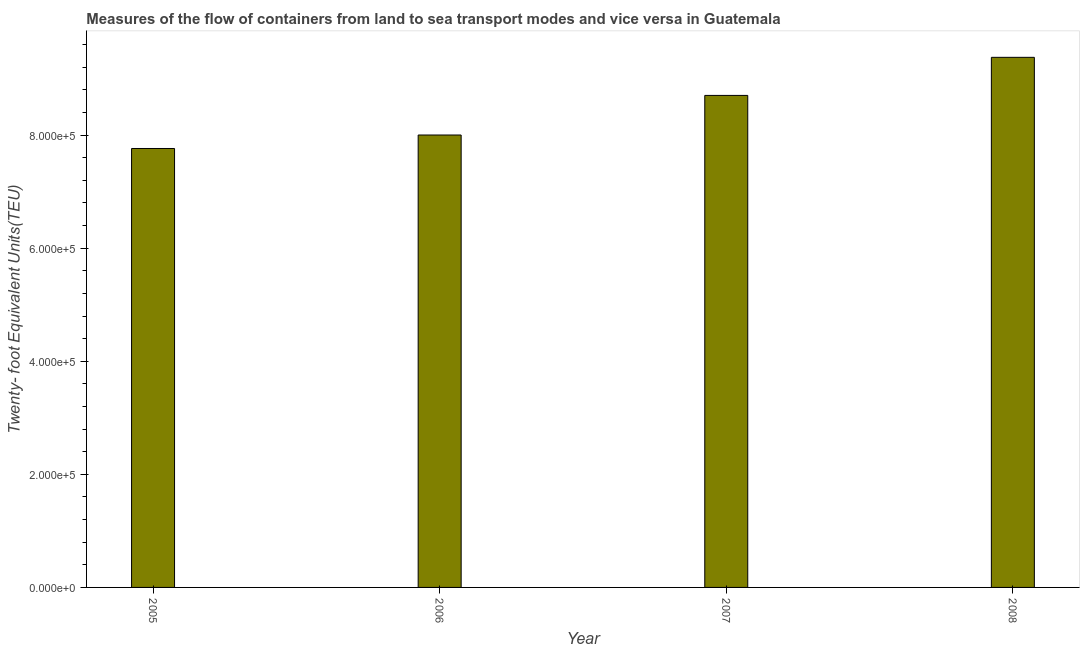Does the graph contain any zero values?
Your answer should be very brief. No. Does the graph contain grids?
Ensure brevity in your answer.  No. What is the title of the graph?
Ensure brevity in your answer.  Measures of the flow of containers from land to sea transport modes and vice versa in Guatemala. What is the label or title of the X-axis?
Provide a succinct answer. Year. What is the label or title of the Y-axis?
Provide a short and direct response. Twenty- foot Equivalent Units(TEU). What is the container port traffic in 2007?
Provide a succinct answer. 8.70e+05. Across all years, what is the maximum container port traffic?
Give a very brief answer. 9.38e+05. Across all years, what is the minimum container port traffic?
Provide a short and direct response. 7.76e+05. In which year was the container port traffic maximum?
Your response must be concise. 2008. What is the sum of the container port traffic?
Your answer should be very brief. 3.38e+06. What is the difference between the container port traffic in 2007 and 2008?
Ensure brevity in your answer.  -6.74e+04. What is the average container port traffic per year?
Your answer should be compact. 8.46e+05. What is the median container port traffic?
Provide a short and direct response. 8.35e+05. What is the ratio of the container port traffic in 2006 to that in 2008?
Offer a very short reply. 0.85. Is the container port traffic in 2006 less than that in 2008?
Your answer should be compact. Yes. What is the difference between the highest and the second highest container port traffic?
Ensure brevity in your answer.  6.74e+04. Is the sum of the container port traffic in 2007 and 2008 greater than the maximum container port traffic across all years?
Provide a short and direct response. Yes. What is the difference between the highest and the lowest container port traffic?
Your answer should be compact. 1.61e+05. In how many years, is the container port traffic greater than the average container port traffic taken over all years?
Provide a short and direct response. 2. Are all the bars in the graph horizontal?
Offer a very short reply. No. How many years are there in the graph?
Ensure brevity in your answer.  4. What is the Twenty- foot Equivalent Units(TEU) in 2005?
Offer a very short reply. 7.76e+05. What is the Twenty- foot Equivalent Units(TEU) of 2006?
Offer a terse response. 8.00e+05. What is the Twenty- foot Equivalent Units(TEU) in 2007?
Make the answer very short. 8.70e+05. What is the Twenty- foot Equivalent Units(TEU) in 2008?
Ensure brevity in your answer.  9.38e+05. What is the difference between the Twenty- foot Equivalent Units(TEU) in 2005 and 2006?
Provide a short and direct response. -2.38e+04. What is the difference between the Twenty- foot Equivalent Units(TEU) in 2005 and 2007?
Provide a succinct answer. -9.39e+04. What is the difference between the Twenty- foot Equivalent Units(TEU) in 2005 and 2008?
Keep it short and to the point. -1.61e+05. What is the difference between the Twenty- foot Equivalent Units(TEU) in 2006 and 2007?
Your answer should be compact. -7.00e+04. What is the difference between the Twenty- foot Equivalent Units(TEU) in 2006 and 2008?
Offer a terse response. -1.37e+05. What is the difference between the Twenty- foot Equivalent Units(TEU) in 2007 and 2008?
Your answer should be very brief. -6.74e+04. What is the ratio of the Twenty- foot Equivalent Units(TEU) in 2005 to that in 2006?
Your answer should be compact. 0.97. What is the ratio of the Twenty- foot Equivalent Units(TEU) in 2005 to that in 2007?
Offer a terse response. 0.89. What is the ratio of the Twenty- foot Equivalent Units(TEU) in 2005 to that in 2008?
Your answer should be very brief. 0.83. What is the ratio of the Twenty- foot Equivalent Units(TEU) in 2006 to that in 2008?
Provide a succinct answer. 0.85. What is the ratio of the Twenty- foot Equivalent Units(TEU) in 2007 to that in 2008?
Make the answer very short. 0.93. 